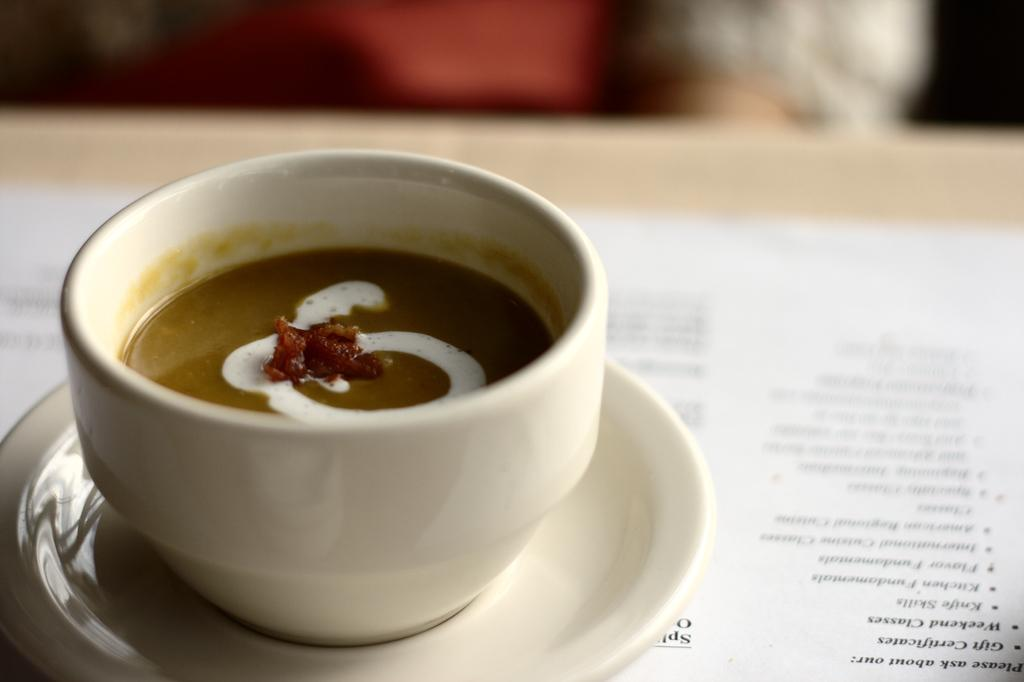What is on the plate in the image? There is a bowl on a plate in the image. What is written on the paper in the image? There is a paper with text written on it in the image. What type of furniture is present in the image? There is a table in the image. How many boys are holding a twig in the image? There are no boys or twigs present in the image. 